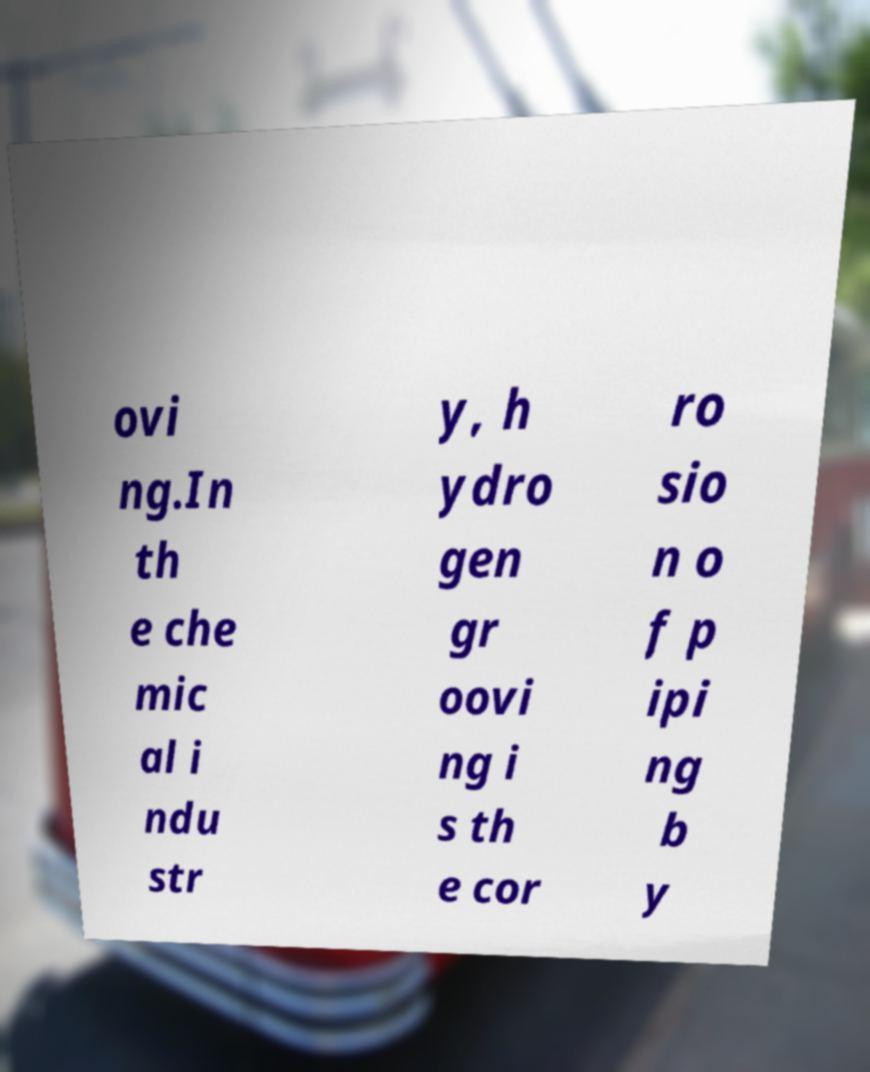Could you extract and type out the text from this image? ovi ng.In th e che mic al i ndu str y, h ydro gen gr oovi ng i s th e cor ro sio n o f p ipi ng b y 